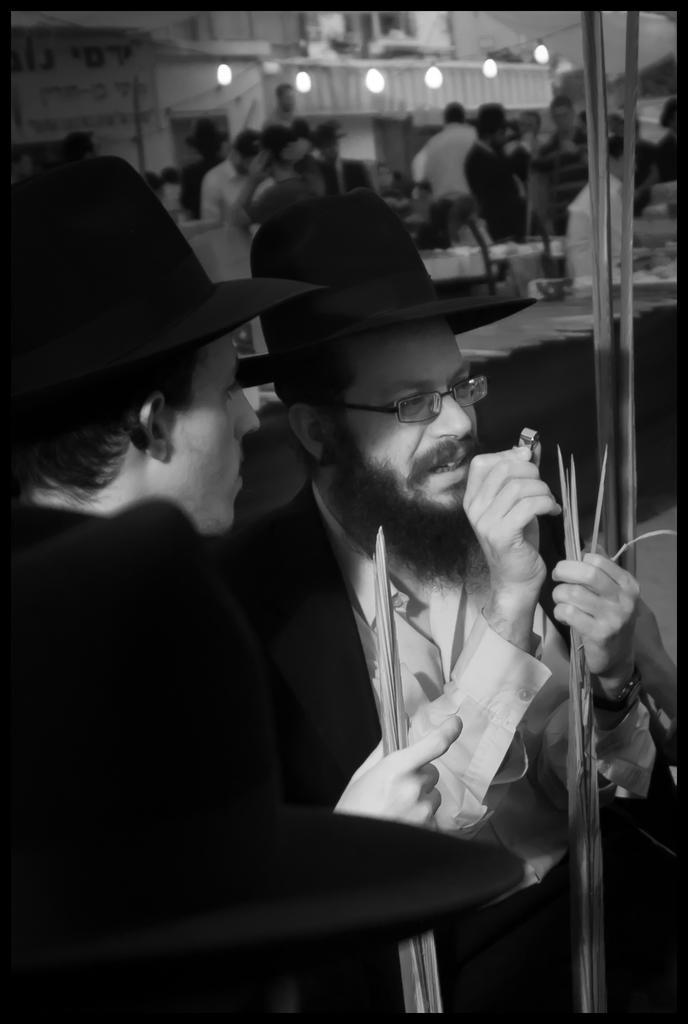Could you give a brief overview of what you see in this image? In this picture I can see two persons wearing hats and holding some objects, behind I can see few people, some tables and lights to the buildings. 